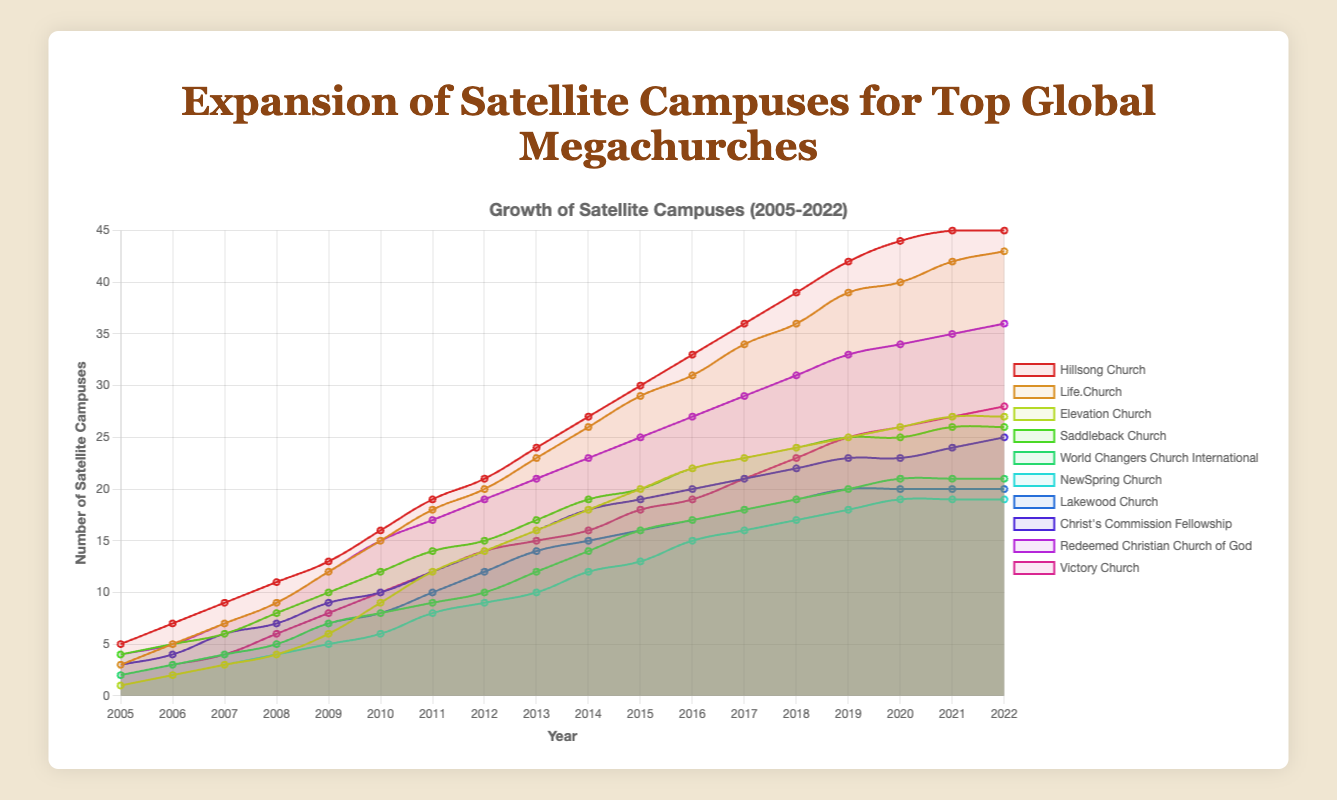What's the total number of satellite campuses established by Hillsong Church by 2022? To find the total number of satellite campuses established by Hillsong Church by 2022, simply refer to the last data point in the Hillsong Church series.
Answer: 45 Which two churches have the same number of satellite campuses in 2020? Look at the lines for all churches in 2020 and identify them having the same y-value. Hillsong Church and Elevation Church both have 27 campuses in 2020.
Answer: Hillsong Church, Elevation Church Which church had the largest increase in satellite campuses between 2005 and 2022? Calculate the difference in the number of campuses between 2005 and 2022 for each church. For Hillsong Church: 45-5=40, Life.Church: 43-3=40, etc. The church with the highest number is Hillsong Church and Life.Church, both increased by 40.
Answer: Hillsong Church, Life.Church Which church's satellite campus expansion appears to plateau around 2018? Look for the churches whose lines become flatter starting from 2018. Hillsong Church's line plateaus during this period.
Answer: Hillsong Church Compare the increase in the number of satellite campuses for Saddleback Church and Victory Church between 2010 and 2020. For Saddleback Church: 25-12=13, For Victory Church: 26-10=16.
Answer: Victory Church What's the average annual increase in satellite campuses for Life.Church from 2005 to 2022? Calculate the total increase first: 43-3=40, then divide by the number of years: 40/(2022-2005)=2.35.
Answer: 2.35 Which church had the slowest growth rate of satellite campuses by 2016? Calculate the growth rate for each church from 2005 to 2016, e.g., for NewSpring Church: 15-1=14, for Victory Church: 19-2=17, etc. The church with the smallest increase is NewSpring Church (14).
Answer: NewSpring Church Identify the church which had a constant number of satellite campuses in the last two years. Check the last two data points for each church to see if there is no change. Hillsong Church and Elevation Church both had no change from 2021 to 2022.
Answer: Hillsong Church, Elevation Church Which church reached 20 satellite campuses first? Identify the year each church reached 20 campuses first. Referring to the data, Life.Church reached 20 campuses first in 2013.
Answer: Life.Church 